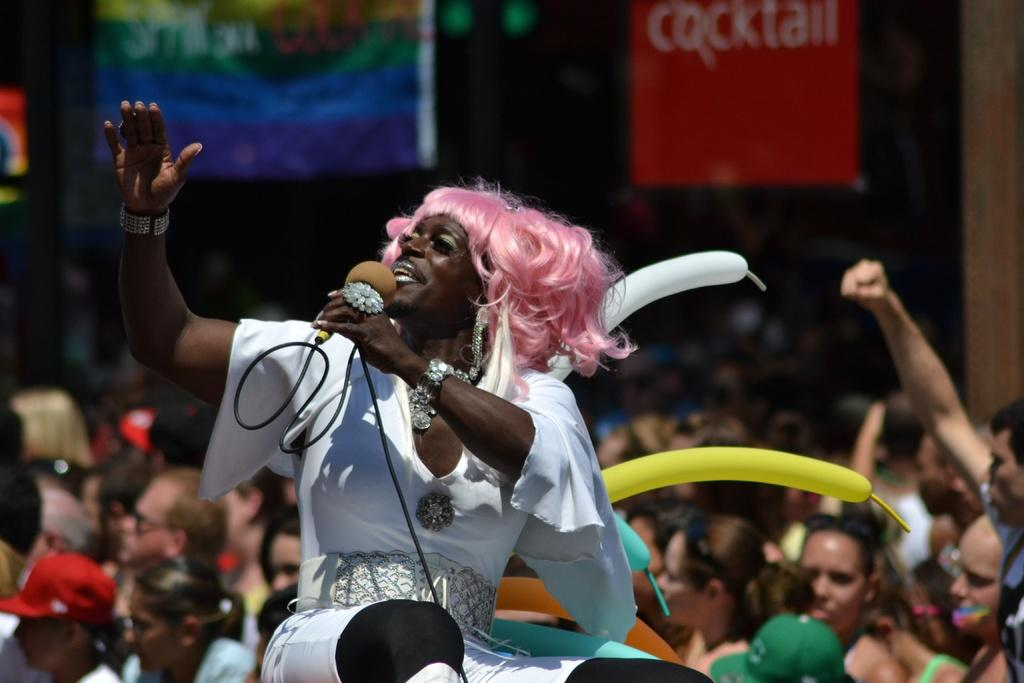What is the appearance of the man in the image? The man in the image is wearing a wig and a white dress. What is the man doing in the image? The man is talking on a microphone. How many people are visible behind the man? There are many people standing behind the man. What type of event might be taking place in the image? The scene appears to be a carnival. What type of apparel is being sold at the airport in the image? There is no airport or apparel being sold in the image; it features a man in a wig and dress talking on a microphone at a carnival. 